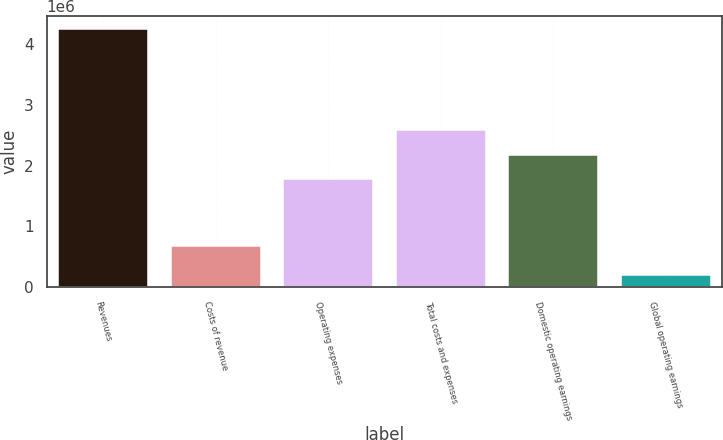Convert chart. <chart><loc_0><loc_0><loc_500><loc_500><bar_chart><fcel>Revenues<fcel>Costs of revenue<fcel>Operating expenses<fcel>Total costs and expenses<fcel>Domestic operating earnings<fcel>Global operating earnings<nl><fcel>4.2451e+06<fcel>676437<fcel>1.77415e+06<fcel>2.58267e+06<fcel>2.17841e+06<fcel>202454<nl></chart> 